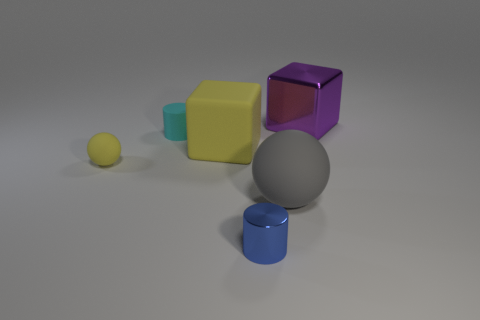What materials are the objects in this image made of? The objects in the image appear to be rendered with different types of materials. The small sphere and the big cube have a matte finish, suggesting a non-reflective, possibly rough texture. In contrast, the small cube and the cylinder exhibit a shiny surface, indicating a more reflective material like polished metal or plastic. 